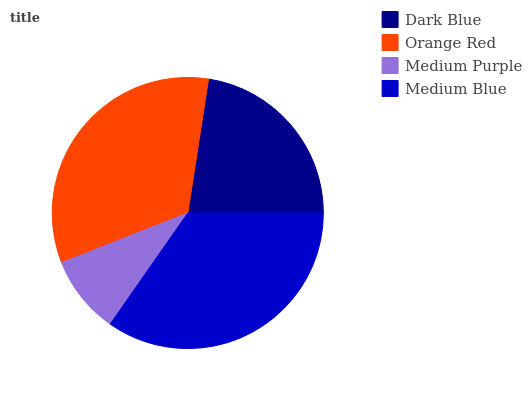Is Medium Purple the minimum?
Answer yes or no. Yes. Is Medium Blue the maximum?
Answer yes or no. Yes. Is Orange Red the minimum?
Answer yes or no. No. Is Orange Red the maximum?
Answer yes or no. No. Is Orange Red greater than Dark Blue?
Answer yes or no. Yes. Is Dark Blue less than Orange Red?
Answer yes or no. Yes. Is Dark Blue greater than Orange Red?
Answer yes or no. No. Is Orange Red less than Dark Blue?
Answer yes or no. No. Is Orange Red the high median?
Answer yes or no. Yes. Is Dark Blue the low median?
Answer yes or no. Yes. Is Medium Blue the high median?
Answer yes or no. No. Is Medium Blue the low median?
Answer yes or no. No. 